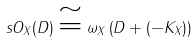Convert formula to latex. <formula><loc_0><loc_0><loc_500><loc_500>\ s O _ { X } ( D ) \cong \omega _ { X } \left ( D + ( - K _ { X } ) \right )</formula> 